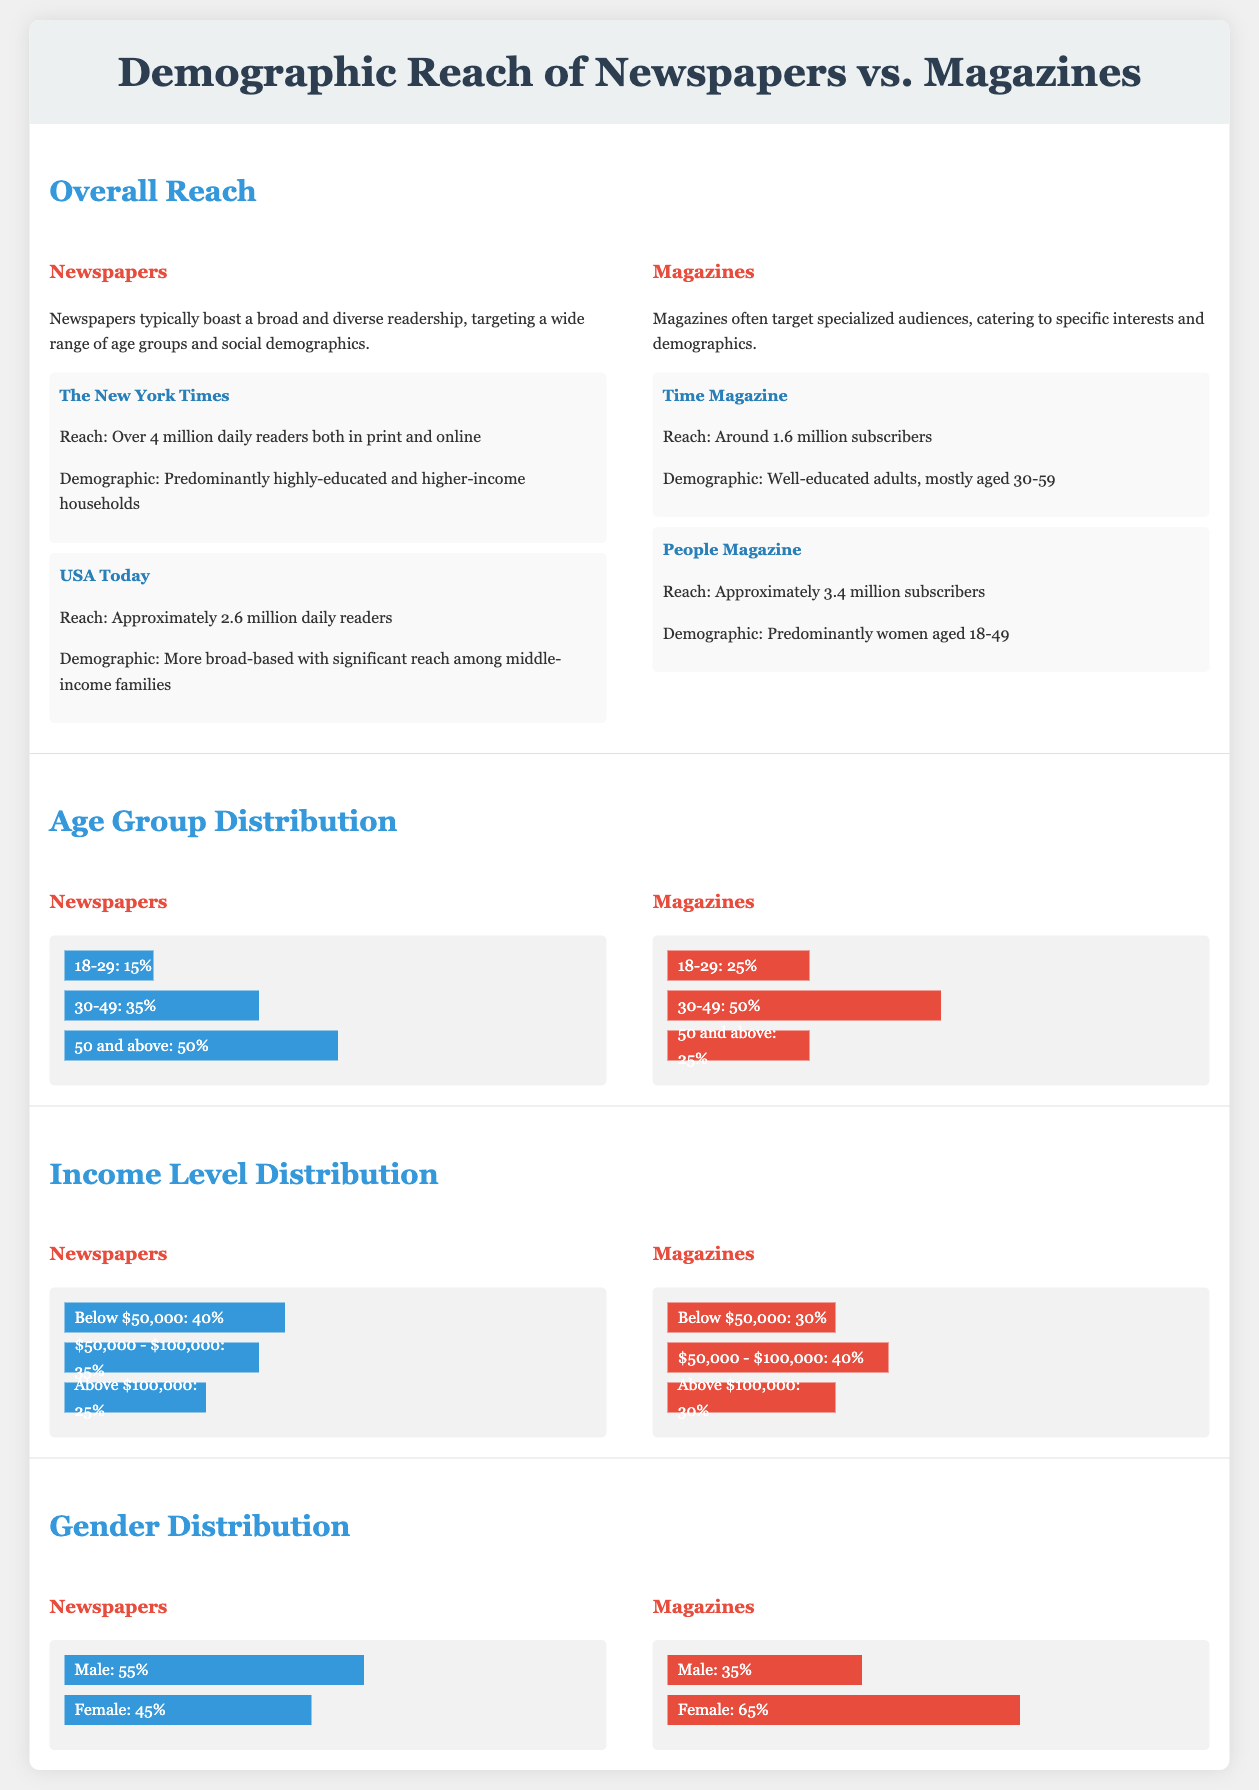what is the reach of The New York Times? The document states that The New York Times has a reach of over 4 million daily readers both in print and online.
Answer: over 4 million what demographic is predominantly targeted by USA Today? According to the document, USA Today targets middle-income families, indicating a broader demographic base.
Answer: middle-income families what percentage of newspaper readers are aged 50 and above? The document shows that 50% of newspaper readers fall into the age group of 50 and above.
Answer: 50% how many subscribers does Time Magazine have? The document indicates that Time Magazine has around 1.6 million subscribers.
Answer: around 1.6 million what is the income level percentage for newspapers among those making below $50,000? The document states that 40% of newspaper readers have an income level below $50,000.
Answer: 40% which gender has a higher reach in newspapers? The document indicates that males make up 55% of newspaper readers, indicating a higher reach for males.
Answer: Male what is the percentage of magazine readers aged 30-49? The document indicates that 50% of magazine readers fall into the age group of 30-49.
Answer: 50% which demographic group is primarily targeted by People Magazine? According to the document, People Magazine primarily targets women aged 18-49.
Answer: women aged 18-49 what is the overall perception of magazine reach according to the document? The document suggests that magazines target specialized audiences, catering to specific interests and demographics.
Answer: specialized audiences 